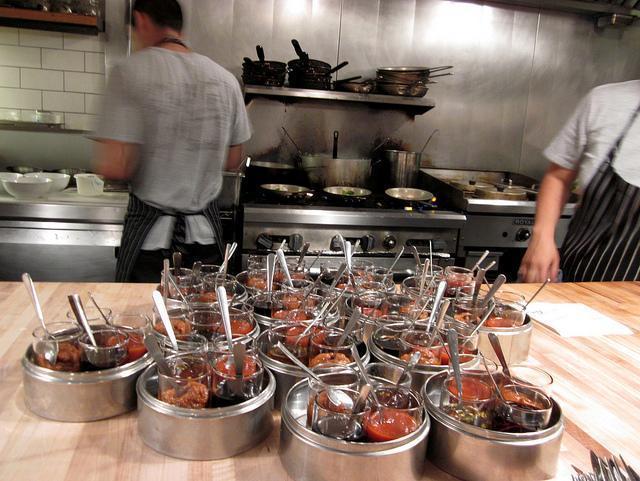How many cups are there?
Give a very brief answer. 7. How many ovens are in the picture?
Give a very brief answer. 3. How many people are in the photo?
Give a very brief answer. 2. How many bowls are there?
Give a very brief answer. 11. How many dining tables are in the photo?
Give a very brief answer. 1. 